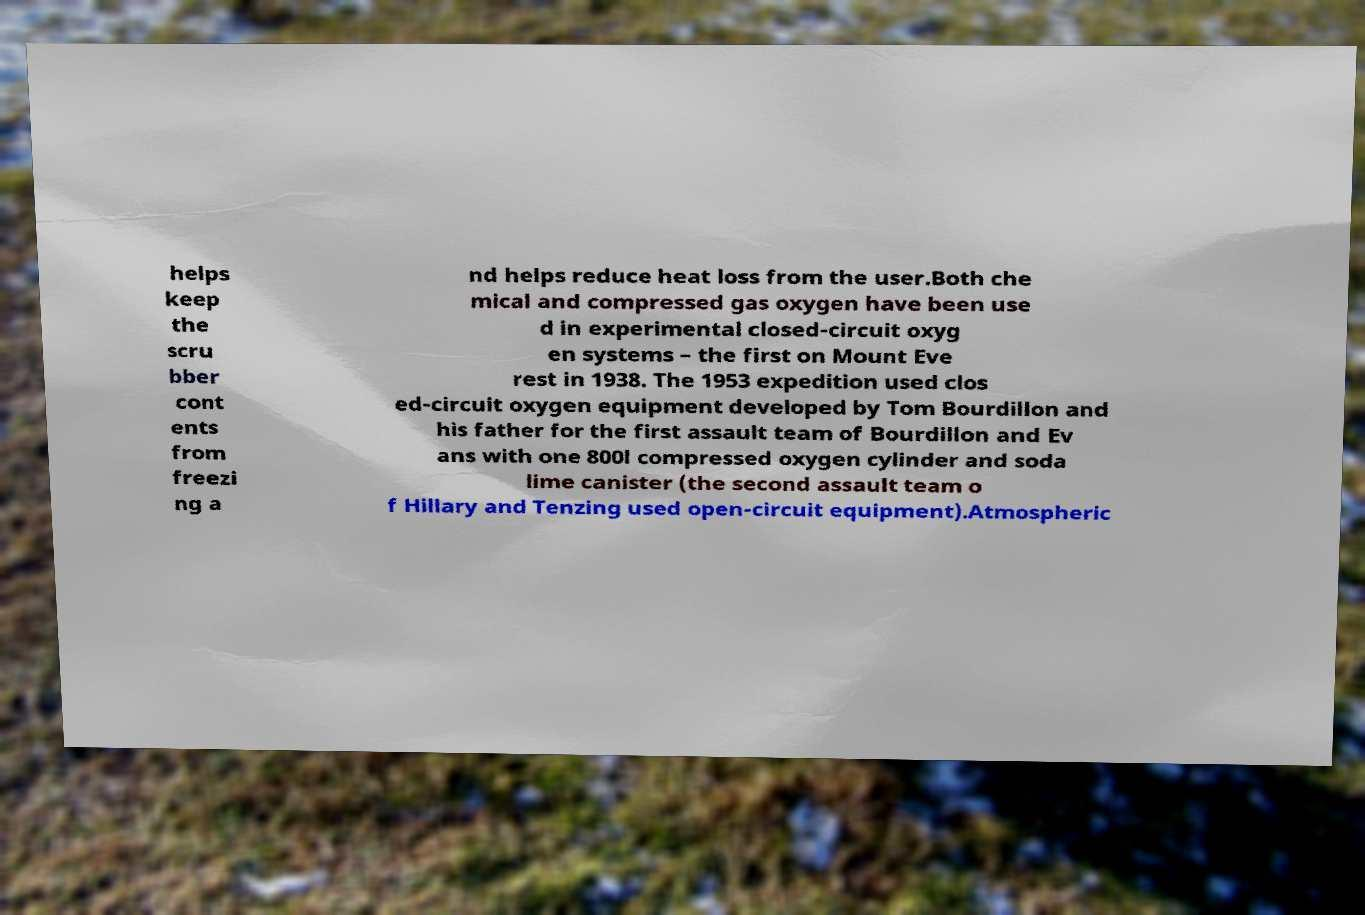Could you assist in decoding the text presented in this image and type it out clearly? helps keep the scru bber cont ents from freezi ng a nd helps reduce heat loss from the user.Both che mical and compressed gas oxygen have been use d in experimental closed-circuit oxyg en systems – the first on Mount Eve rest in 1938. The 1953 expedition used clos ed-circuit oxygen equipment developed by Tom Bourdillon and his father for the first assault team of Bourdillon and Ev ans with one 800l compressed oxygen cylinder and soda lime canister (the second assault team o f Hillary and Tenzing used open-circuit equipment).Atmospheric 